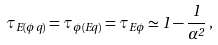<formula> <loc_0><loc_0><loc_500><loc_500>\tau _ { E ( \phi q ) } = \tau _ { \phi ( E q ) } = \tau _ { E \phi } \simeq 1 - \frac { 1 } { \alpha ^ { 2 } } \, ,</formula> 